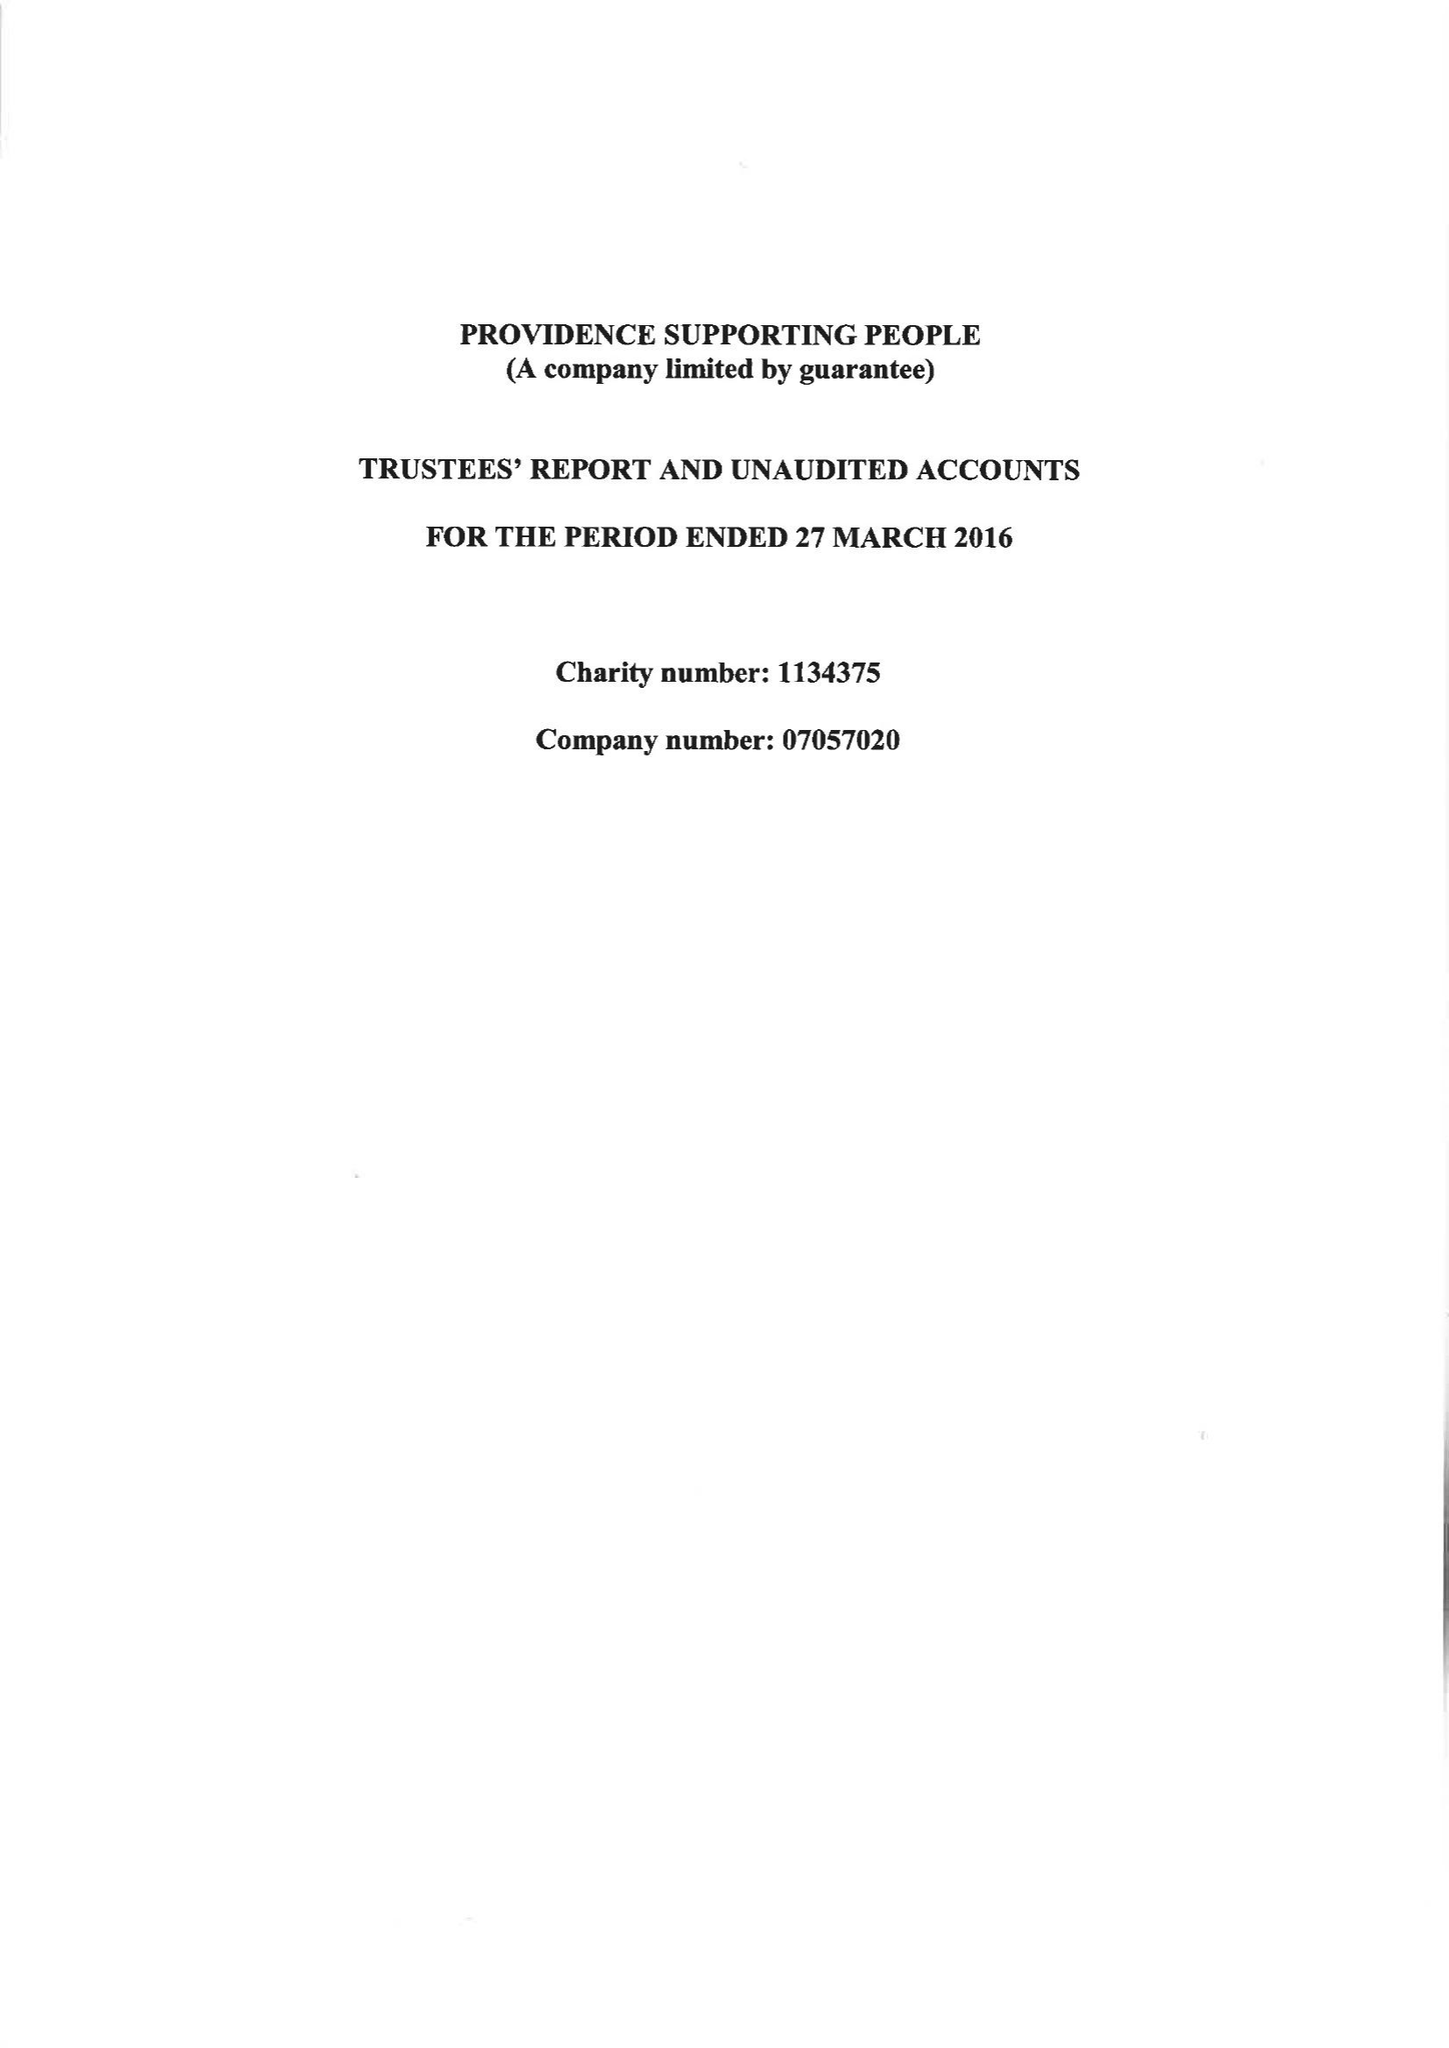What is the value for the charity_name?
Answer the question using a single word or phrase. Providence Supporting People 